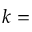<formula> <loc_0><loc_0><loc_500><loc_500>k =</formula> 